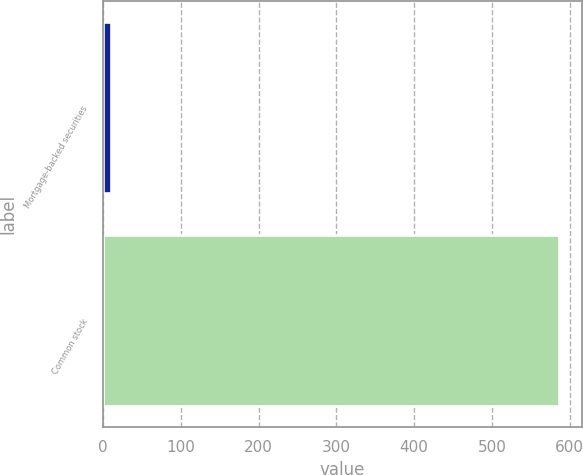Convert chart to OTSL. <chart><loc_0><loc_0><loc_500><loc_500><bar_chart><fcel>Mortgage-backed securities<fcel>Common stock<nl><fcel>10<fcel>586<nl></chart> 